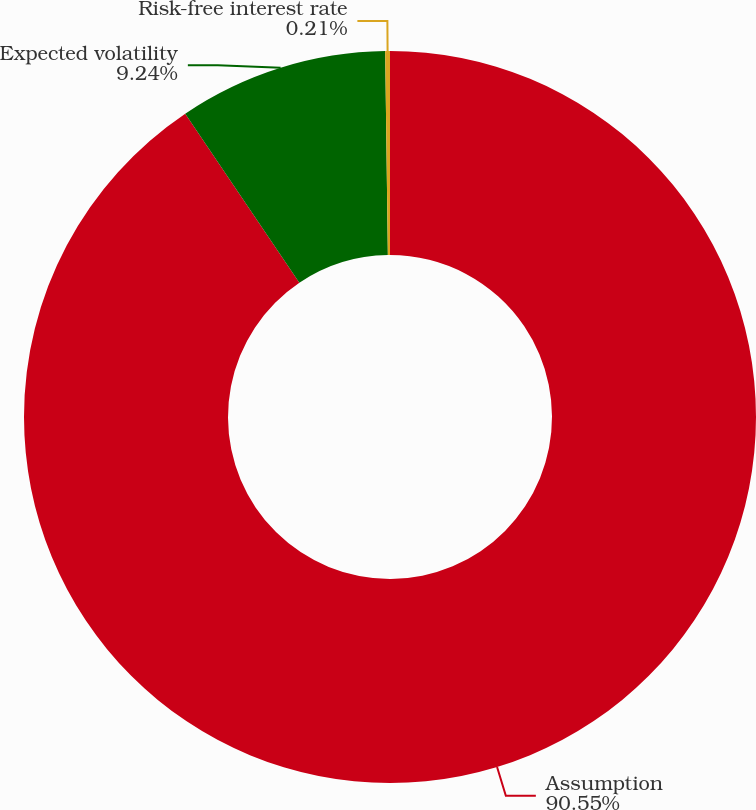<chart> <loc_0><loc_0><loc_500><loc_500><pie_chart><fcel>Assumption<fcel>Expected volatility<fcel>Risk-free interest rate<nl><fcel>90.55%<fcel>9.24%<fcel>0.21%<nl></chart> 